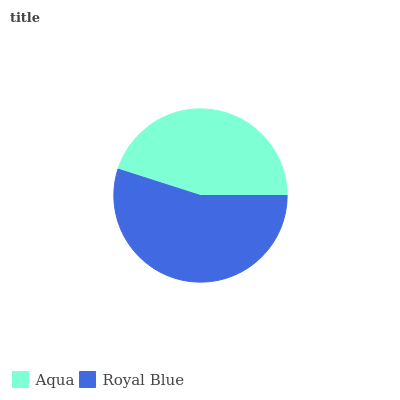Is Aqua the minimum?
Answer yes or no. Yes. Is Royal Blue the maximum?
Answer yes or no. Yes. Is Royal Blue the minimum?
Answer yes or no. No. Is Royal Blue greater than Aqua?
Answer yes or no. Yes. Is Aqua less than Royal Blue?
Answer yes or no. Yes. Is Aqua greater than Royal Blue?
Answer yes or no. No. Is Royal Blue less than Aqua?
Answer yes or no. No. Is Royal Blue the high median?
Answer yes or no. Yes. Is Aqua the low median?
Answer yes or no. Yes. Is Aqua the high median?
Answer yes or no. No. Is Royal Blue the low median?
Answer yes or no. No. 